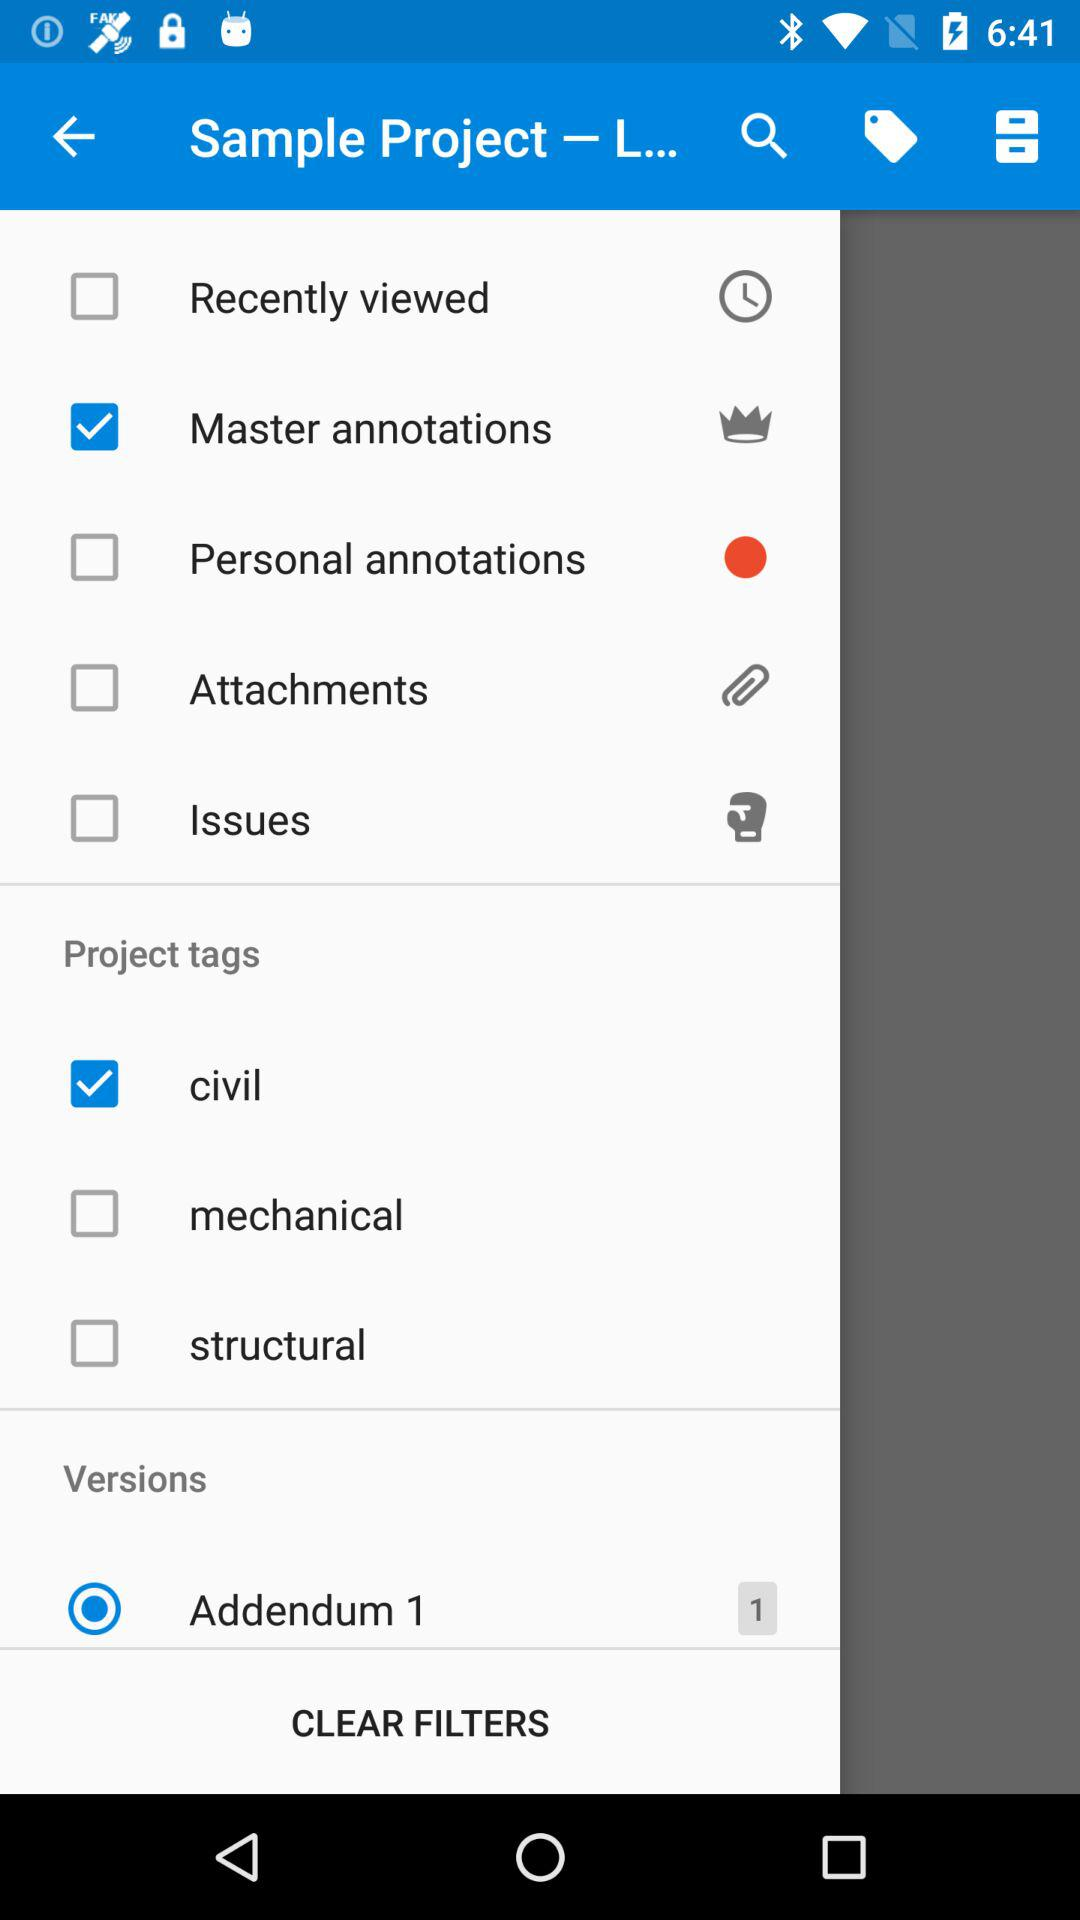What is selected in project tags? The selected option is "civil". 